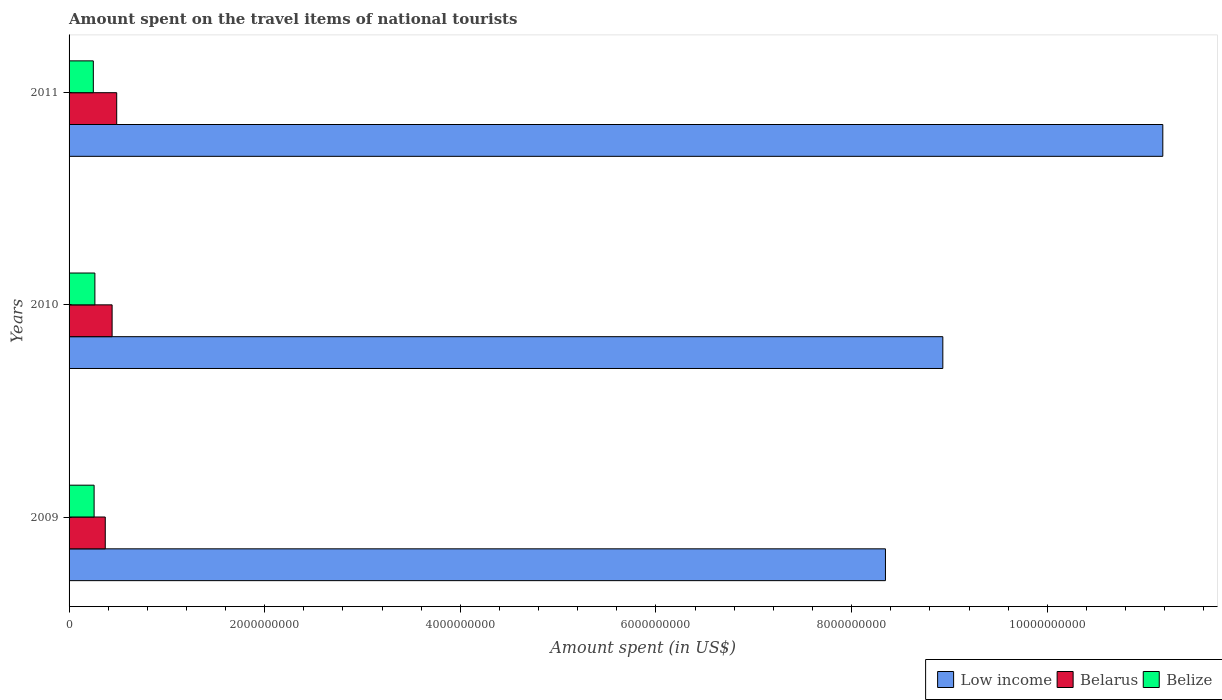Are the number of bars per tick equal to the number of legend labels?
Ensure brevity in your answer.  Yes. How many bars are there on the 2nd tick from the top?
Give a very brief answer. 3. What is the amount spent on the travel items of national tourists in Belize in 2009?
Give a very brief answer. 2.56e+08. Across all years, what is the maximum amount spent on the travel items of national tourists in Belize?
Your answer should be very brief. 2.64e+08. Across all years, what is the minimum amount spent on the travel items of national tourists in Belize?
Your answer should be compact. 2.48e+08. In which year was the amount spent on the travel items of national tourists in Low income maximum?
Provide a succinct answer. 2011. In which year was the amount spent on the travel items of national tourists in Belarus minimum?
Your answer should be compact. 2009. What is the total amount spent on the travel items of national tourists in Belize in the graph?
Provide a short and direct response. 7.68e+08. What is the difference between the amount spent on the travel items of national tourists in Belize in 2009 and that in 2010?
Provide a short and direct response. -8.00e+06. What is the difference between the amount spent on the travel items of national tourists in Belize in 2010 and the amount spent on the travel items of national tourists in Low income in 2011?
Keep it short and to the point. -1.09e+1. What is the average amount spent on the travel items of national tourists in Low income per year?
Make the answer very short. 9.49e+09. In the year 2010, what is the difference between the amount spent on the travel items of national tourists in Belize and amount spent on the travel items of national tourists in Belarus?
Keep it short and to the point. -1.76e+08. What is the ratio of the amount spent on the travel items of national tourists in Belarus in 2009 to that in 2011?
Ensure brevity in your answer.  0.76. Is the difference between the amount spent on the travel items of national tourists in Belize in 2009 and 2011 greater than the difference between the amount spent on the travel items of national tourists in Belarus in 2009 and 2011?
Offer a terse response. Yes. What is the difference between the highest and the second highest amount spent on the travel items of national tourists in Belarus?
Your response must be concise. 4.70e+07. What is the difference between the highest and the lowest amount spent on the travel items of national tourists in Belarus?
Offer a very short reply. 1.17e+08. In how many years, is the amount spent on the travel items of national tourists in Belize greater than the average amount spent on the travel items of national tourists in Belize taken over all years?
Give a very brief answer. 1. What does the 2nd bar from the top in 2011 represents?
Your response must be concise. Belarus. What does the 2nd bar from the bottom in 2010 represents?
Provide a succinct answer. Belarus. Is it the case that in every year, the sum of the amount spent on the travel items of national tourists in Belize and amount spent on the travel items of national tourists in Belarus is greater than the amount spent on the travel items of national tourists in Low income?
Provide a short and direct response. No. How many bars are there?
Make the answer very short. 9. Are all the bars in the graph horizontal?
Provide a short and direct response. Yes. How many years are there in the graph?
Offer a very short reply. 3. Where does the legend appear in the graph?
Your response must be concise. Bottom right. How are the legend labels stacked?
Your response must be concise. Horizontal. What is the title of the graph?
Your response must be concise. Amount spent on the travel items of national tourists. What is the label or title of the X-axis?
Provide a short and direct response. Amount spent (in US$). What is the label or title of the Y-axis?
Your answer should be compact. Years. What is the Amount spent (in US$) of Low income in 2009?
Provide a short and direct response. 8.35e+09. What is the Amount spent (in US$) of Belarus in 2009?
Offer a very short reply. 3.70e+08. What is the Amount spent (in US$) in Belize in 2009?
Provide a short and direct response. 2.56e+08. What is the Amount spent (in US$) in Low income in 2010?
Offer a very short reply. 8.93e+09. What is the Amount spent (in US$) of Belarus in 2010?
Your answer should be compact. 4.40e+08. What is the Amount spent (in US$) in Belize in 2010?
Your response must be concise. 2.64e+08. What is the Amount spent (in US$) in Low income in 2011?
Provide a succinct answer. 1.12e+1. What is the Amount spent (in US$) in Belarus in 2011?
Offer a terse response. 4.87e+08. What is the Amount spent (in US$) in Belize in 2011?
Give a very brief answer. 2.48e+08. Across all years, what is the maximum Amount spent (in US$) in Low income?
Offer a very short reply. 1.12e+1. Across all years, what is the maximum Amount spent (in US$) in Belarus?
Give a very brief answer. 4.87e+08. Across all years, what is the maximum Amount spent (in US$) of Belize?
Provide a short and direct response. 2.64e+08. Across all years, what is the minimum Amount spent (in US$) in Low income?
Make the answer very short. 8.35e+09. Across all years, what is the minimum Amount spent (in US$) in Belarus?
Your answer should be very brief. 3.70e+08. Across all years, what is the minimum Amount spent (in US$) in Belize?
Your answer should be compact. 2.48e+08. What is the total Amount spent (in US$) in Low income in the graph?
Give a very brief answer. 2.85e+1. What is the total Amount spent (in US$) of Belarus in the graph?
Offer a very short reply. 1.30e+09. What is the total Amount spent (in US$) in Belize in the graph?
Offer a terse response. 7.68e+08. What is the difference between the Amount spent (in US$) in Low income in 2009 and that in 2010?
Your answer should be compact. -5.86e+08. What is the difference between the Amount spent (in US$) of Belarus in 2009 and that in 2010?
Provide a succinct answer. -7.00e+07. What is the difference between the Amount spent (in US$) in Belize in 2009 and that in 2010?
Ensure brevity in your answer.  -8.00e+06. What is the difference between the Amount spent (in US$) of Low income in 2009 and that in 2011?
Give a very brief answer. -2.84e+09. What is the difference between the Amount spent (in US$) in Belarus in 2009 and that in 2011?
Give a very brief answer. -1.17e+08. What is the difference between the Amount spent (in US$) in Low income in 2010 and that in 2011?
Offer a terse response. -2.25e+09. What is the difference between the Amount spent (in US$) in Belarus in 2010 and that in 2011?
Your answer should be compact. -4.70e+07. What is the difference between the Amount spent (in US$) in Belize in 2010 and that in 2011?
Ensure brevity in your answer.  1.60e+07. What is the difference between the Amount spent (in US$) of Low income in 2009 and the Amount spent (in US$) of Belarus in 2010?
Keep it short and to the point. 7.91e+09. What is the difference between the Amount spent (in US$) in Low income in 2009 and the Amount spent (in US$) in Belize in 2010?
Your response must be concise. 8.08e+09. What is the difference between the Amount spent (in US$) of Belarus in 2009 and the Amount spent (in US$) of Belize in 2010?
Provide a short and direct response. 1.06e+08. What is the difference between the Amount spent (in US$) of Low income in 2009 and the Amount spent (in US$) of Belarus in 2011?
Your response must be concise. 7.86e+09. What is the difference between the Amount spent (in US$) of Low income in 2009 and the Amount spent (in US$) of Belize in 2011?
Give a very brief answer. 8.10e+09. What is the difference between the Amount spent (in US$) of Belarus in 2009 and the Amount spent (in US$) of Belize in 2011?
Offer a terse response. 1.22e+08. What is the difference between the Amount spent (in US$) in Low income in 2010 and the Amount spent (in US$) in Belarus in 2011?
Ensure brevity in your answer.  8.45e+09. What is the difference between the Amount spent (in US$) of Low income in 2010 and the Amount spent (in US$) of Belize in 2011?
Provide a succinct answer. 8.68e+09. What is the difference between the Amount spent (in US$) of Belarus in 2010 and the Amount spent (in US$) of Belize in 2011?
Make the answer very short. 1.92e+08. What is the average Amount spent (in US$) of Low income per year?
Provide a short and direct response. 9.49e+09. What is the average Amount spent (in US$) of Belarus per year?
Provide a short and direct response. 4.32e+08. What is the average Amount spent (in US$) in Belize per year?
Offer a terse response. 2.56e+08. In the year 2009, what is the difference between the Amount spent (in US$) in Low income and Amount spent (in US$) in Belarus?
Your answer should be very brief. 7.98e+09. In the year 2009, what is the difference between the Amount spent (in US$) in Low income and Amount spent (in US$) in Belize?
Provide a short and direct response. 8.09e+09. In the year 2009, what is the difference between the Amount spent (in US$) in Belarus and Amount spent (in US$) in Belize?
Offer a very short reply. 1.14e+08. In the year 2010, what is the difference between the Amount spent (in US$) of Low income and Amount spent (in US$) of Belarus?
Provide a short and direct response. 8.49e+09. In the year 2010, what is the difference between the Amount spent (in US$) in Low income and Amount spent (in US$) in Belize?
Ensure brevity in your answer.  8.67e+09. In the year 2010, what is the difference between the Amount spent (in US$) of Belarus and Amount spent (in US$) of Belize?
Offer a very short reply. 1.76e+08. In the year 2011, what is the difference between the Amount spent (in US$) of Low income and Amount spent (in US$) of Belarus?
Ensure brevity in your answer.  1.07e+1. In the year 2011, what is the difference between the Amount spent (in US$) in Low income and Amount spent (in US$) in Belize?
Ensure brevity in your answer.  1.09e+1. In the year 2011, what is the difference between the Amount spent (in US$) in Belarus and Amount spent (in US$) in Belize?
Offer a very short reply. 2.39e+08. What is the ratio of the Amount spent (in US$) of Low income in 2009 to that in 2010?
Ensure brevity in your answer.  0.93. What is the ratio of the Amount spent (in US$) in Belarus in 2009 to that in 2010?
Ensure brevity in your answer.  0.84. What is the ratio of the Amount spent (in US$) in Belize in 2009 to that in 2010?
Your response must be concise. 0.97. What is the ratio of the Amount spent (in US$) of Low income in 2009 to that in 2011?
Give a very brief answer. 0.75. What is the ratio of the Amount spent (in US$) in Belarus in 2009 to that in 2011?
Ensure brevity in your answer.  0.76. What is the ratio of the Amount spent (in US$) of Belize in 2009 to that in 2011?
Provide a short and direct response. 1.03. What is the ratio of the Amount spent (in US$) of Low income in 2010 to that in 2011?
Make the answer very short. 0.8. What is the ratio of the Amount spent (in US$) in Belarus in 2010 to that in 2011?
Your answer should be compact. 0.9. What is the ratio of the Amount spent (in US$) in Belize in 2010 to that in 2011?
Provide a short and direct response. 1.06. What is the difference between the highest and the second highest Amount spent (in US$) in Low income?
Offer a very short reply. 2.25e+09. What is the difference between the highest and the second highest Amount spent (in US$) of Belarus?
Make the answer very short. 4.70e+07. What is the difference between the highest and the lowest Amount spent (in US$) in Low income?
Your answer should be very brief. 2.84e+09. What is the difference between the highest and the lowest Amount spent (in US$) of Belarus?
Provide a short and direct response. 1.17e+08. What is the difference between the highest and the lowest Amount spent (in US$) in Belize?
Ensure brevity in your answer.  1.60e+07. 